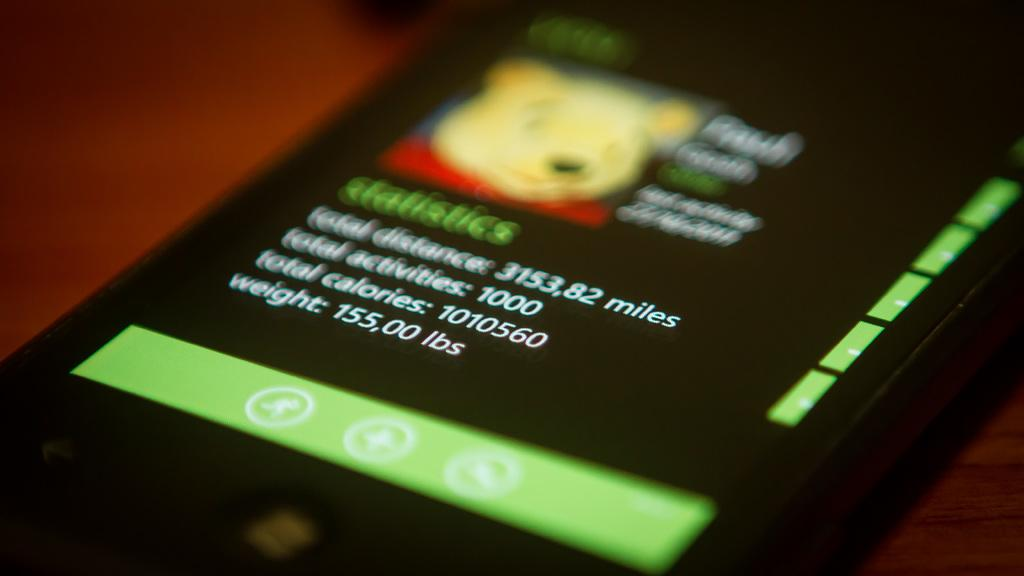<image>
Write a terse but informative summary of the picture. A phone screen with a picture of winnie the pooh on it. 